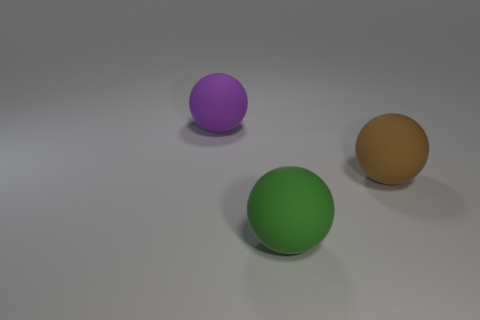What number of balls are large green matte objects or large brown objects?
Give a very brief answer. 2. Is there any other thing that is the same shape as the green rubber object?
Offer a very short reply. Yes. Is the number of big purple matte objects left of the large green object greater than the number of spheres on the left side of the large purple rubber object?
Ensure brevity in your answer.  Yes. There is a large rubber object behind the big brown object; what number of brown objects are to the right of it?
Offer a very short reply. 1. How many things are either cyan things or rubber balls?
Keep it short and to the point. 3. Is the shape of the purple thing the same as the brown matte thing?
Provide a short and direct response. Yes. What is the green sphere made of?
Offer a very short reply. Rubber. What number of large balls are on the left side of the green ball and to the right of the green ball?
Make the answer very short. 0. Is the green rubber thing the same size as the purple object?
Provide a succinct answer. Yes. There is a object that is in front of the brown thing; is it the same size as the purple sphere?
Ensure brevity in your answer.  Yes. 